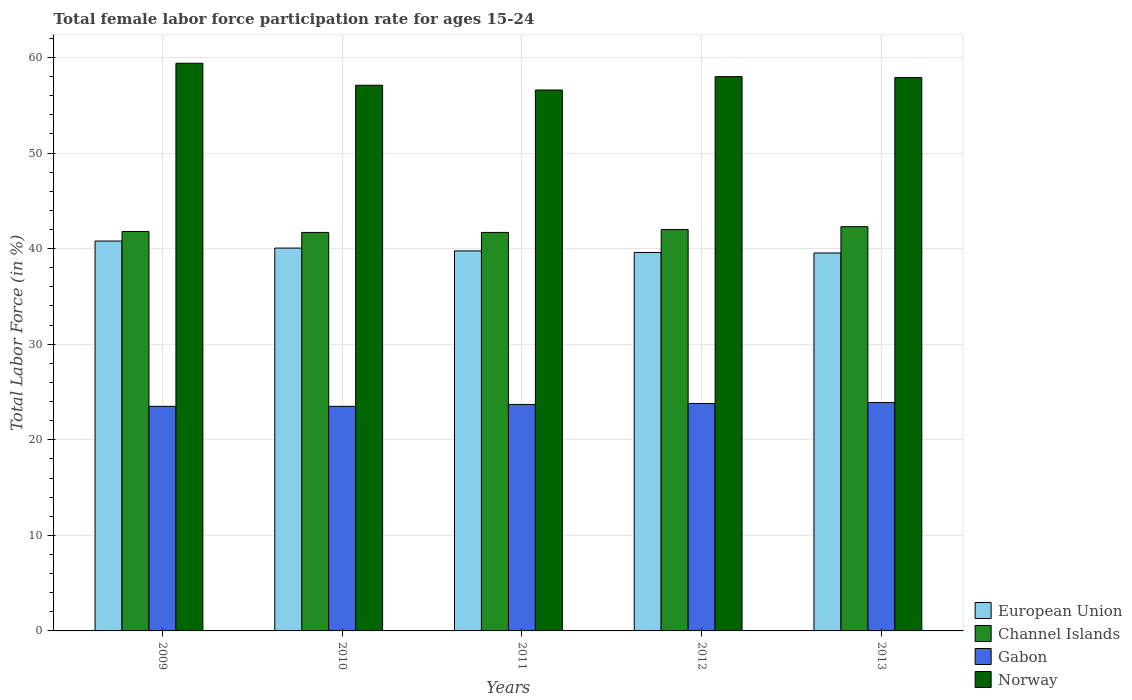How many different coloured bars are there?
Offer a very short reply. 4. Are the number of bars on each tick of the X-axis equal?
Offer a very short reply. Yes. How many bars are there on the 5th tick from the right?
Your answer should be very brief. 4. What is the label of the 4th group of bars from the left?
Provide a succinct answer. 2012. What is the female labor force participation rate in Norway in 2010?
Your answer should be compact. 57.1. Across all years, what is the maximum female labor force participation rate in European Union?
Your answer should be very brief. 40.8. Across all years, what is the minimum female labor force participation rate in Norway?
Provide a short and direct response. 56.6. What is the total female labor force participation rate in European Union in the graph?
Your response must be concise. 199.77. What is the difference between the female labor force participation rate in Channel Islands in 2010 and that in 2013?
Your response must be concise. -0.6. What is the difference between the female labor force participation rate in Channel Islands in 2010 and the female labor force participation rate in European Union in 2012?
Offer a terse response. 2.1. What is the average female labor force participation rate in European Union per year?
Provide a succinct answer. 39.95. In the year 2012, what is the difference between the female labor force participation rate in European Union and female labor force participation rate in Channel Islands?
Offer a very short reply. -2.4. What is the ratio of the female labor force participation rate in Gabon in 2010 to that in 2013?
Offer a very short reply. 0.98. What is the difference between the highest and the second highest female labor force participation rate in Norway?
Your answer should be compact. 1.4. What is the difference between the highest and the lowest female labor force participation rate in European Union?
Offer a very short reply. 1.25. In how many years, is the female labor force participation rate in European Union greater than the average female labor force participation rate in European Union taken over all years?
Your response must be concise. 2. Is the sum of the female labor force participation rate in Channel Islands in 2011 and 2012 greater than the maximum female labor force participation rate in Norway across all years?
Provide a succinct answer. Yes. What does the 2nd bar from the left in 2010 represents?
Ensure brevity in your answer.  Channel Islands. What does the 4th bar from the right in 2009 represents?
Provide a succinct answer. European Union. Are all the bars in the graph horizontal?
Give a very brief answer. No. Does the graph contain grids?
Provide a succinct answer. Yes. How are the legend labels stacked?
Provide a succinct answer. Vertical. What is the title of the graph?
Your response must be concise. Total female labor force participation rate for ages 15-24. Does "Czech Republic" appear as one of the legend labels in the graph?
Give a very brief answer. No. What is the label or title of the X-axis?
Provide a short and direct response. Years. What is the label or title of the Y-axis?
Give a very brief answer. Total Labor Force (in %). What is the Total Labor Force (in %) in European Union in 2009?
Give a very brief answer. 40.8. What is the Total Labor Force (in %) of Channel Islands in 2009?
Your response must be concise. 41.8. What is the Total Labor Force (in %) of Gabon in 2009?
Offer a terse response. 23.5. What is the Total Labor Force (in %) of Norway in 2009?
Make the answer very short. 59.4. What is the Total Labor Force (in %) in European Union in 2010?
Keep it short and to the point. 40.06. What is the Total Labor Force (in %) of Channel Islands in 2010?
Give a very brief answer. 41.7. What is the Total Labor Force (in %) in Norway in 2010?
Offer a very short reply. 57.1. What is the Total Labor Force (in %) in European Union in 2011?
Provide a succinct answer. 39.76. What is the Total Labor Force (in %) in Channel Islands in 2011?
Offer a very short reply. 41.7. What is the Total Labor Force (in %) of Gabon in 2011?
Make the answer very short. 23.7. What is the Total Labor Force (in %) in Norway in 2011?
Give a very brief answer. 56.6. What is the Total Labor Force (in %) of European Union in 2012?
Provide a succinct answer. 39.6. What is the Total Labor Force (in %) of Gabon in 2012?
Your answer should be very brief. 23.8. What is the Total Labor Force (in %) of Norway in 2012?
Offer a very short reply. 58. What is the Total Labor Force (in %) in European Union in 2013?
Your answer should be very brief. 39.55. What is the Total Labor Force (in %) in Channel Islands in 2013?
Offer a very short reply. 42.3. What is the Total Labor Force (in %) of Gabon in 2013?
Your answer should be compact. 23.9. What is the Total Labor Force (in %) of Norway in 2013?
Make the answer very short. 57.9. Across all years, what is the maximum Total Labor Force (in %) in European Union?
Provide a succinct answer. 40.8. Across all years, what is the maximum Total Labor Force (in %) in Channel Islands?
Offer a terse response. 42.3. Across all years, what is the maximum Total Labor Force (in %) of Gabon?
Offer a terse response. 23.9. Across all years, what is the maximum Total Labor Force (in %) of Norway?
Your answer should be compact. 59.4. Across all years, what is the minimum Total Labor Force (in %) in European Union?
Your answer should be compact. 39.55. Across all years, what is the minimum Total Labor Force (in %) in Channel Islands?
Keep it short and to the point. 41.7. Across all years, what is the minimum Total Labor Force (in %) in Gabon?
Offer a very short reply. 23.5. Across all years, what is the minimum Total Labor Force (in %) in Norway?
Your answer should be very brief. 56.6. What is the total Total Labor Force (in %) of European Union in the graph?
Keep it short and to the point. 199.77. What is the total Total Labor Force (in %) in Channel Islands in the graph?
Keep it short and to the point. 209.5. What is the total Total Labor Force (in %) of Gabon in the graph?
Keep it short and to the point. 118.4. What is the total Total Labor Force (in %) in Norway in the graph?
Ensure brevity in your answer.  289. What is the difference between the Total Labor Force (in %) in European Union in 2009 and that in 2010?
Make the answer very short. 0.74. What is the difference between the Total Labor Force (in %) in Gabon in 2009 and that in 2010?
Ensure brevity in your answer.  0. What is the difference between the Total Labor Force (in %) in European Union in 2009 and that in 2011?
Ensure brevity in your answer.  1.03. What is the difference between the Total Labor Force (in %) of Channel Islands in 2009 and that in 2011?
Ensure brevity in your answer.  0.1. What is the difference between the Total Labor Force (in %) in Gabon in 2009 and that in 2011?
Keep it short and to the point. -0.2. What is the difference between the Total Labor Force (in %) of Norway in 2009 and that in 2011?
Offer a terse response. 2.8. What is the difference between the Total Labor Force (in %) of European Union in 2009 and that in 2012?
Keep it short and to the point. 1.2. What is the difference between the Total Labor Force (in %) of Gabon in 2009 and that in 2012?
Make the answer very short. -0.3. What is the difference between the Total Labor Force (in %) in European Union in 2009 and that in 2013?
Provide a short and direct response. 1.25. What is the difference between the Total Labor Force (in %) in Channel Islands in 2009 and that in 2013?
Give a very brief answer. -0.5. What is the difference between the Total Labor Force (in %) of Norway in 2009 and that in 2013?
Give a very brief answer. 1.5. What is the difference between the Total Labor Force (in %) in European Union in 2010 and that in 2011?
Make the answer very short. 0.29. What is the difference between the Total Labor Force (in %) in Gabon in 2010 and that in 2011?
Your response must be concise. -0.2. What is the difference between the Total Labor Force (in %) of Norway in 2010 and that in 2011?
Keep it short and to the point. 0.5. What is the difference between the Total Labor Force (in %) of European Union in 2010 and that in 2012?
Provide a succinct answer. 0.46. What is the difference between the Total Labor Force (in %) of Channel Islands in 2010 and that in 2012?
Give a very brief answer. -0.3. What is the difference between the Total Labor Force (in %) of Gabon in 2010 and that in 2012?
Provide a succinct answer. -0.3. What is the difference between the Total Labor Force (in %) in Norway in 2010 and that in 2012?
Ensure brevity in your answer.  -0.9. What is the difference between the Total Labor Force (in %) of European Union in 2010 and that in 2013?
Your answer should be compact. 0.51. What is the difference between the Total Labor Force (in %) in Channel Islands in 2010 and that in 2013?
Give a very brief answer. -0.6. What is the difference between the Total Labor Force (in %) in Norway in 2010 and that in 2013?
Ensure brevity in your answer.  -0.8. What is the difference between the Total Labor Force (in %) of European Union in 2011 and that in 2012?
Make the answer very short. 0.17. What is the difference between the Total Labor Force (in %) of Channel Islands in 2011 and that in 2012?
Your answer should be compact. -0.3. What is the difference between the Total Labor Force (in %) of European Union in 2011 and that in 2013?
Offer a very short reply. 0.22. What is the difference between the Total Labor Force (in %) in European Union in 2012 and that in 2013?
Your answer should be very brief. 0.05. What is the difference between the Total Labor Force (in %) of European Union in 2009 and the Total Labor Force (in %) of Channel Islands in 2010?
Your answer should be very brief. -0.9. What is the difference between the Total Labor Force (in %) in European Union in 2009 and the Total Labor Force (in %) in Gabon in 2010?
Your answer should be compact. 17.3. What is the difference between the Total Labor Force (in %) in European Union in 2009 and the Total Labor Force (in %) in Norway in 2010?
Your answer should be very brief. -16.3. What is the difference between the Total Labor Force (in %) of Channel Islands in 2009 and the Total Labor Force (in %) of Gabon in 2010?
Your response must be concise. 18.3. What is the difference between the Total Labor Force (in %) of Channel Islands in 2009 and the Total Labor Force (in %) of Norway in 2010?
Give a very brief answer. -15.3. What is the difference between the Total Labor Force (in %) of Gabon in 2009 and the Total Labor Force (in %) of Norway in 2010?
Give a very brief answer. -33.6. What is the difference between the Total Labor Force (in %) of European Union in 2009 and the Total Labor Force (in %) of Channel Islands in 2011?
Give a very brief answer. -0.9. What is the difference between the Total Labor Force (in %) of European Union in 2009 and the Total Labor Force (in %) of Gabon in 2011?
Make the answer very short. 17.1. What is the difference between the Total Labor Force (in %) of European Union in 2009 and the Total Labor Force (in %) of Norway in 2011?
Provide a succinct answer. -15.8. What is the difference between the Total Labor Force (in %) in Channel Islands in 2009 and the Total Labor Force (in %) in Norway in 2011?
Ensure brevity in your answer.  -14.8. What is the difference between the Total Labor Force (in %) of Gabon in 2009 and the Total Labor Force (in %) of Norway in 2011?
Provide a short and direct response. -33.1. What is the difference between the Total Labor Force (in %) of European Union in 2009 and the Total Labor Force (in %) of Channel Islands in 2012?
Provide a succinct answer. -1.2. What is the difference between the Total Labor Force (in %) of European Union in 2009 and the Total Labor Force (in %) of Gabon in 2012?
Ensure brevity in your answer.  17. What is the difference between the Total Labor Force (in %) in European Union in 2009 and the Total Labor Force (in %) in Norway in 2012?
Provide a short and direct response. -17.2. What is the difference between the Total Labor Force (in %) of Channel Islands in 2009 and the Total Labor Force (in %) of Gabon in 2012?
Offer a very short reply. 18. What is the difference between the Total Labor Force (in %) of Channel Islands in 2009 and the Total Labor Force (in %) of Norway in 2012?
Provide a short and direct response. -16.2. What is the difference between the Total Labor Force (in %) of Gabon in 2009 and the Total Labor Force (in %) of Norway in 2012?
Your answer should be compact. -34.5. What is the difference between the Total Labor Force (in %) of European Union in 2009 and the Total Labor Force (in %) of Channel Islands in 2013?
Offer a terse response. -1.5. What is the difference between the Total Labor Force (in %) of European Union in 2009 and the Total Labor Force (in %) of Gabon in 2013?
Provide a succinct answer. 16.9. What is the difference between the Total Labor Force (in %) of European Union in 2009 and the Total Labor Force (in %) of Norway in 2013?
Offer a very short reply. -17.1. What is the difference between the Total Labor Force (in %) in Channel Islands in 2009 and the Total Labor Force (in %) in Gabon in 2013?
Provide a short and direct response. 17.9. What is the difference between the Total Labor Force (in %) of Channel Islands in 2009 and the Total Labor Force (in %) of Norway in 2013?
Offer a very short reply. -16.1. What is the difference between the Total Labor Force (in %) in Gabon in 2009 and the Total Labor Force (in %) in Norway in 2013?
Your answer should be very brief. -34.4. What is the difference between the Total Labor Force (in %) in European Union in 2010 and the Total Labor Force (in %) in Channel Islands in 2011?
Your response must be concise. -1.64. What is the difference between the Total Labor Force (in %) of European Union in 2010 and the Total Labor Force (in %) of Gabon in 2011?
Make the answer very short. 16.36. What is the difference between the Total Labor Force (in %) of European Union in 2010 and the Total Labor Force (in %) of Norway in 2011?
Provide a succinct answer. -16.54. What is the difference between the Total Labor Force (in %) of Channel Islands in 2010 and the Total Labor Force (in %) of Gabon in 2011?
Your answer should be very brief. 18. What is the difference between the Total Labor Force (in %) in Channel Islands in 2010 and the Total Labor Force (in %) in Norway in 2011?
Provide a short and direct response. -14.9. What is the difference between the Total Labor Force (in %) in Gabon in 2010 and the Total Labor Force (in %) in Norway in 2011?
Your response must be concise. -33.1. What is the difference between the Total Labor Force (in %) of European Union in 2010 and the Total Labor Force (in %) of Channel Islands in 2012?
Ensure brevity in your answer.  -1.94. What is the difference between the Total Labor Force (in %) in European Union in 2010 and the Total Labor Force (in %) in Gabon in 2012?
Offer a very short reply. 16.26. What is the difference between the Total Labor Force (in %) in European Union in 2010 and the Total Labor Force (in %) in Norway in 2012?
Provide a succinct answer. -17.94. What is the difference between the Total Labor Force (in %) of Channel Islands in 2010 and the Total Labor Force (in %) of Norway in 2012?
Your response must be concise. -16.3. What is the difference between the Total Labor Force (in %) in Gabon in 2010 and the Total Labor Force (in %) in Norway in 2012?
Make the answer very short. -34.5. What is the difference between the Total Labor Force (in %) in European Union in 2010 and the Total Labor Force (in %) in Channel Islands in 2013?
Offer a very short reply. -2.24. What is the difference between the Total Labor Force (in %) of European Union in 2010 and the Total Labor Force (in %) of Gabon in 2013?
Make the answer very short. 16.16. What is the difference between the Total Labor Force (in %) in European Union in 2010 and the Total Labor Force (in %) in Norway in 2013?
Make the answer very short. -17.84. What is the difference between the Total Labor Force (in %) of Channel Islands in 2010 and the Total Labor Force (in %) of Norway in 2013?
Give a very brief answer. -16.2. What is the difference between the Total Labor Force (in %) in Gabon in 2010 and the Total Labor Force (in %) in Norway in 2013?
Offer a very short reply. -34.4. What is the difference between the Total Labor Force (in %) of European Union in 2011 and the Total Labor Force (in %) of Channel Islands in 2012?
Ensure brevity in your answer.  -2.24. What is the difference between the Total Labor Force (in %) of European Union in 2011 and the Total Labor Force (in %) of Gabon in 2012?
Ensure brevity in your answer.  15.96. What is the difference between the Total Labor Force (in %) of European Union in 2011 and the Total Labor Force (in %) of Norway in 2012?
Your response must be concise. -18.24. What is the difference between the Total Labor Force (in %) of Channel Islands in 2011 and the Total Labor Force (in %) of Norway in 2012?
Give a very brief answer. -16.3. What is the difference between the Total Labor Force (in %) of Gabon in 2011 and the Total Labor Force (in %) of Norway in 2012?
Offer a very short reply. -34.3. What is the difference between the Total Labor Force (in %) of European Union in 2011 and the Total Labor Force (in %) of Channel Islands in 2013?
Offer a very short reply. -2.54. What is the difference between the Total Labor Force (in %) in European Union in 2011 and the Total Labor Force (in %) in Gabon in 2013?
Offer a terse response. 15.86. What is the difference between the Total Labor Force (in %) of European Union in 2011 and the Total Labor Force (in %) of Norway in 2013?
Your answer should be very brief. -18.14. What is the difference between the Total Labor Force (in %) in Channel Islands in 2011 and the Total Labor Force (in %) in Gabon in 2013?
Your answer should be compact. 17.8. What is the difference between the Total Labor Force (in %) of Channel Islands in 2011 and the Total Labor Force (in %) of Norway in 2013?
Make the answer very short. -16.2. What is the difference between the Total Labor Force (in %) in Gabon in 2011 and the Total Labor Force (in %) in Norway in 2013?
Make the answer very short. -34.2. What is the difference between the Total Labor Force (in %) of European Union in 2012 and the Total Labor Force (in %) of Channel Islands in 2013?
Ensure brevity in your answer.  -2.7. What is the difference between the Total Labor Force (in %) in European Union in 2012 and the Total Labor Force (in %) in Gabon in 2013?
Ensure brevity in your answer.  15.7. What is the difference between the Total Labor Force (in %) of European Union in 2012 and the Total Labor Force (in %) of Norway in 2013?
Your answer should be compact. -18.3. What is the difference between the Total Labor Force (in %) of Channel Islands in 2012 and the Total Labor Force (in %) of Gabon in 2013?
Give a very brief answer. 18.1. What is the difference between the Total Labor Force (in %) in Channel Islands in 2012 and the Total Labor Force (in %) in Norway in 2013?
Keep it short and to the point. -15.9. What is the difference between the Total Labor Force (in %) of Gabon in 2012 and the Total Labor Force (in %) of Norway in 2013?
Offer a terse response. -34.1. What is the average Total Labor Force (in %) of European Union per year?
Ensure brevity in your answer.  39.95. What is the average Total Labor Force (in %) of Channel Islands per year?
Your response must be concise. 41.9. What is the average Total Labor Force (in %) in Gabon per year?
Offer a very short reply. 23.68. What is the average Total Labor Force (in %) in Norway per year?
Offer a terse response. 57.8. In the year 2009, what is the difference between the Total Labor Force (in %) in European Union and Total Labor Force (in %) in Channel Islands?
Give a very brief answer. -1. In the year 2009, what is the difference between the Total Labor Force (in %) of European Union and Total Labor Force (in %) of Gabon?
Ensure brevity in your answer.  17.3. In the year 2009, what is the difference between the Total Labor Force (in %) of European Union and Total Labor Force (in %) of Norway?
Give a very brief answer. -18.6. In the year 2009, what is the difference between the Total Labor Force (in %) of Channel Islands and Total Labor Force (in %) of Norway?
Provide a short and direct response. -17.6. In the year 2009, what is the difference between the Total Labor Force (in %) in Gabon and Total Labor Force (in %) in Norway?
Provide a short and direct response. -35.9. In the year 2010, what is the difference between the Total Labor Force (in %) of European Union and Total Labor Force (in %) of Channel Islands?
Keep it short and to the point. -1.64. In the year 2010, what is the difference between the Total Labor Force (in %) of European Union and Total Labor Force (in %) of Gabon?
Your response must be concise. 16.56. In the year 2010, what is the difference between the Total Labor Force (in %) of European Union and Total Labor Force (in %) of Norway?
Your response must be concise. -17.04. In the year 2010, what is the difference between the Total Labor Force (in %) of Channel Islands and Total Labor Force (in %) of Norway?
Provide a short and direct response. -15.4. In the year 2010, what is the difference between the Total Labor Force (in %) of Gabon and Total Labor Force (in %) of Norway?
Provide a succinct answer. -33.6. In the year 2011, what is the difference between the Total Labor Force (in %) of European Union and Total Labor Force (in %) of Channel Islands?
Offer a terse response. -1.94. In the year 2011, what is the difference between the Total Labor Force (in %) in European Union and Total Labor Force (in %) in Gabon?
Provide a short and direct response. 16.06. In the year 2011, what is the difference between the Total Labor Force (in %) in European Union and Total Labor Force (in %) in Norway?
Offer a terse response. -16.84. In the year 2011, what is the difference between the Total Labor Force (in %) of Channel Islands and Total Labor Force (in %) of Gabon?
Provide a succinct answer. 18. In the year 2011, what is the difference between the Total Labor Force (in %) in Channel Islands and Total Labor Force (in %) in Norway?
Provide a short and direct response. -14.9. In the year 2011, what is the difference between the Total Labor Force (in %) of Gabon and Total Labor Force (in %) of Norway?
Your answer should be very brief. -32.9. In the year 2012, what is the difference between the Total Labor Force (in %) of European Union and Total Labor Force (in %) of Channel Islands?
Your answer should be very brief. -2.4. In the year 2012, what is the difference between the Total Labor Force (in %) of European Union and Total Labor Force (in %) of Gabon?
Your answer should be very brief. 15.8. In the year 2012, what is the difference between the Total Labor Force (in %) of European Union and Total Labor Force (in %) of Norway?
Make the answer very short. -18.4. In the year 2012, what is the difference between the Total Labor Force (in %) of Channel Islands and Total Labor Force (in %) of Norway?
Give a very brief answer. -16. In the year 2012, what is the difference between the Total Labor Force (in %) in Gabon and Total Labor Force (in %) in Norway?
Your response must be concise. -34.2. In the year 2013, what is the difference between the Total Labor Force (in %) in European Union and Total Labor Force (in %) in Channel Islands?
Your answer should be very brief. -2.75. In the year 2013, what is the difference between the Total Labor Force (in %) in European Union and Total Labor Force (in %) in Gabon?
Provide a short and direct response. 15.65. In the year 2013, what is the difference between the Total Labor Force (in %) of European Union and Total Labor Force (in %) of Norway?
Your answer should be compact. -18.35. In the year 2013, what is the difference between the Total Labor Force (in %) of Channel Islands and Total Labor Force (in %) of Gabon?
Offer a very short reply. 18.4. In the year 2013, what is the difference between the Total Labor Force (in %) of Channel Islands and Total Labor Force (in %) of Norway?
Your answer should be compact. -15.6. In the year 2013, what is the difference between the Total Labor Force (in %) in Gabon and Total Labor Force (in %) in Norway?
Your answer should be very brief. -34. What is the ratio of the Total Labor Force (in %) of European Union in 2009 to that in 2010?
Your response must be concise. 1.02. What is the ratio of the Total Labor Force (in %) of Norway in 2009 to that in 2010?
Provide a succinct answer. 1.04. What is the ratio of the Total Labor Force (in %) in European Union in 2009 to that in 2011?
Your answer should be compact. 1.03. What is the ratio of the Total Labor Force (in %) in Channel Islands in 2009 to that in 2011?
Provide a succinct answer. 1. What is the ratio of the Total Labor Force (in %) of Gabon in 2009 to that in 2011?
Make the answer very short. 0.99. What is the ratio of the Total Labor Force (in %) in Norway in 2009 to that in 2011?
Offer a terse response. 1.05. What is the ratio of the Total Labor Force (in %) in European Union in 2009 to that in 2012?
Your response must be concise. 1.03. What is the ratio of the Total Labor Force (in %) in Channel Islands in 2009 to that in 2012?
Your answer should be very brief. 1. What is the ratio of the Total Labor Force (in %) of Gabon in 2009 to that in 2012?
Make the answer very short. 0.99. What is the ratio of the Total Labor Force (in %) of Norway in 2009 to that in 2012?
Your answer should be compact. 1.02. What is the ratio of the Total Labor Force (in %) of European Union in 2009 to that in 2013?
Your answer should be very brief. 1.03. What is the ratio of the Total Labor Force (in %) in Channel Islands in 2009 to that in 2013?
Keep it short and to the point. 0.99. What is the ratio of the Total Labor Force (in %) of Gabon in 2009 to that in 2013?
Provide a succinct answer. 0.98. What is the ratio of the Total Labor Force (in %) in Norway in 2009 to that in 2013?
Make the answer very short. 1.03. What is the ratio of the Total Labor Force (in %) in European Union in 2010 to that in 2011?
Your response must be concise. 1.01. What is the ratio of the Total Labor Force (in %) in Norway in 2010 to that in 2011?
Your answer should be compact. 1.01. What is the ratio of the Total Labor Force (in %) in European Union in 2010 to that in 2012?
Make the answer very short. 1.01. What is the ratio of the Total Labor Force (in %) in Channel Islands in 2010 to that in 2012?
Your answer should be compact. 0.99. What is the ratio of the Total Labor Force (in %) of Gabon in 2010 to that in 2012?
Your response must be concise. 0.99. What is the ratio of the Total Labor Force (in %) of Norway in 2010 to that in 2012?
Give a very brief answer. 0.98. What is the ratio of the Total Labor Force (in %) of European Union in 2010 to that in 2013?
Offer a terse response. 1.01. What is the ratio of the Total Labor Force (in %) in Channel Islands in 2010 to that in 2013?
Your response must be concise. 0.99. What is the ratio of the Total Labor Force (in %) in Gabon in 2010 to that in 2013?
Provide a short and direct response. 0.98. What is the ratio of the Total Labor Force (in %) of Norway in 2010 to that in 2013?
Make the answer very short. 0.99. What is the ratio of the Total Labor Force (in %) of Gabon in 2011 to that in 2012?
Ensure brevity in your answer.  1. What is the ratio of the Total Labor Force (in %) of Norway in 2011 to that in 2012?
Keep it short and to the point. 0.98. What is the ratio of the Total Labor Force (in %) in European Union in 2011 to that in 2013?
Offer a terse response. 1.01. What is the ratio of the Total Labor Force (in %) in Channel Islands in 2011 to that in 2013?
Offer a terse response. 0.99. What is the ratio of the Total Labor Force (in %) in Gabon in 2011 to that in 2013?
Keep it short and to the point. 0.99. What is the ratio of the Total Labor Force (in %) of Norway in 2011 to that in 2013?
Offer a terse response. 0.98. What is the ratio of the Total Labor Force (in %) in European Union in 2012 to that in 2013?
Provide a succinct answer. 1. What is the ratio of the Total Labor Force (in %) in Norway in 2012 to that in 2013?
Keep it short and to the point. 1. What is the difference between the highest and the second highest Total Labor Force (in %) of European Union?
Your response must be concise. 0.74. What is the difference between the highest and the second highest Total Labor Force (in %) of Gabon?
Make the answer very short. 0.1. What is the difference between the highest and the lowest Total Labor Force (in %) in European Union?
Ensure brevity in your answer.  1.25. What is the difference between the highest and the lowest Total Labor Force (in %) in Channel Islands?
Your answer should be very brief. 0.6. What is the difference between the highest and the lowest Total Labor Force (in %) in Gabon?
Offer a very short reply. 0.4. What is the difference between the highest and the lowest Total Labor Force (in %) of Norway?
Your answer should be compact. 2.8. 